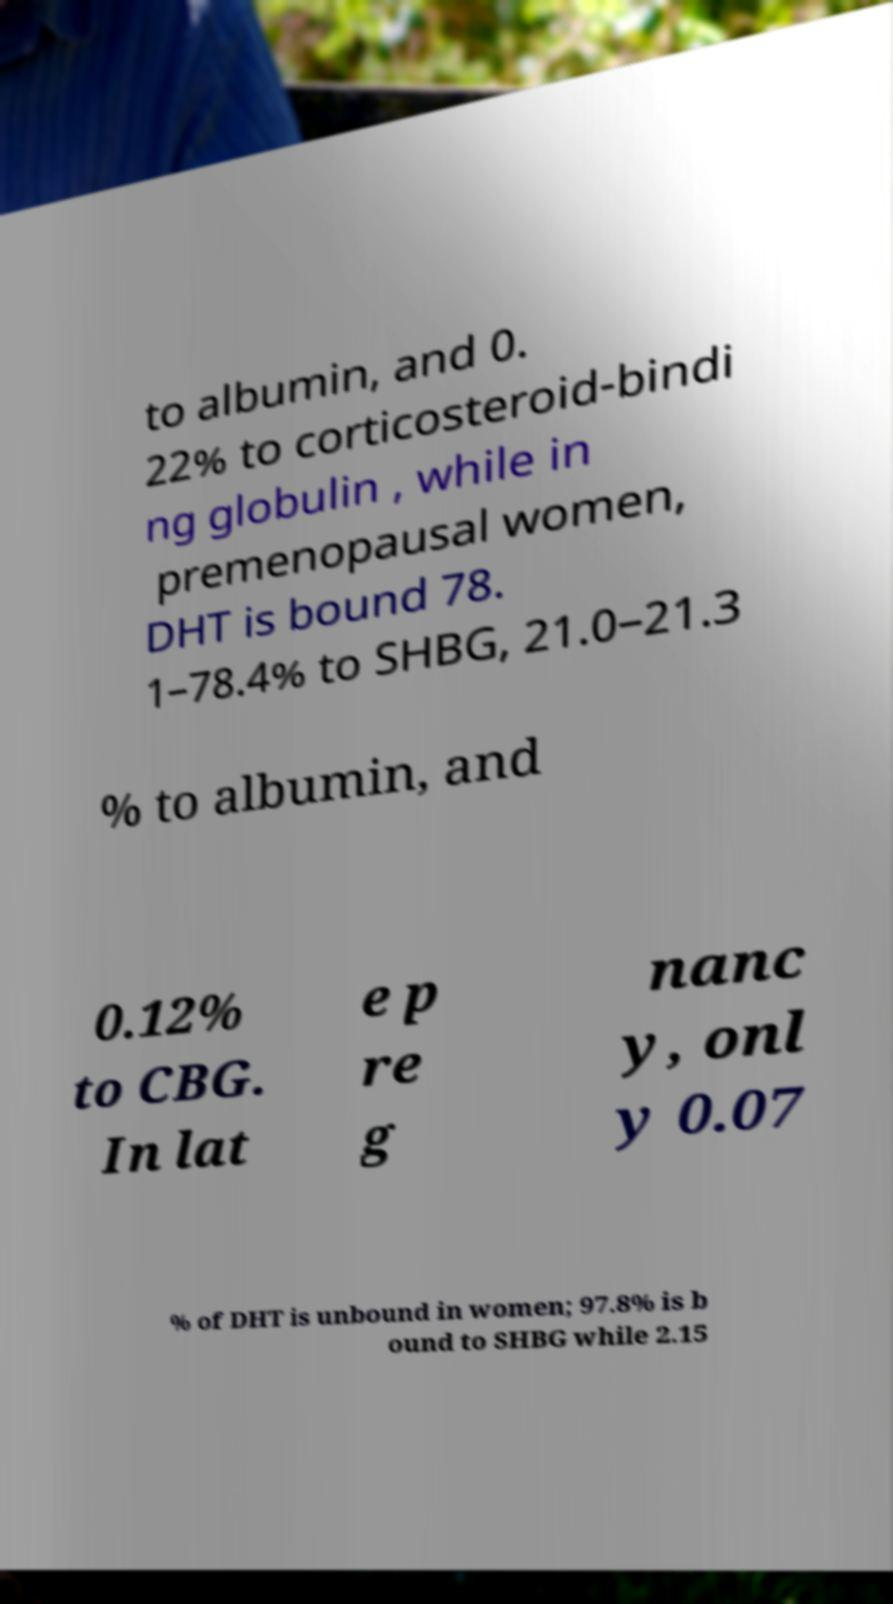For documentation purposes, I need the text within this image transcribed. Could you provide that? to albumin, and 0. 22% to corticosteroid-bindi ng globulin , while in premenopausal women, DHT is bound 78. 1–78.4% to SHBG, 21.0–21.3 % to albumin, and 0.12% to CBG. In lat e p re g nanc y, onl y 0.07 % of DHT is unbound in women; 97.8% is b ound to SHBG while 2.15 